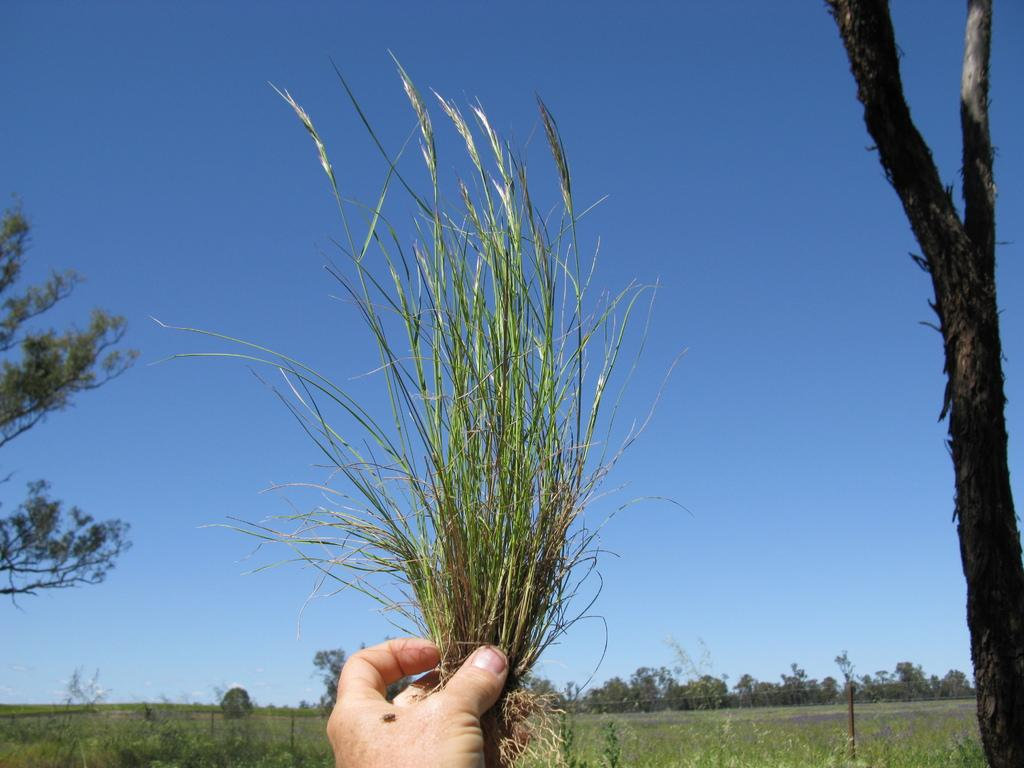What is the main subject in the center of the image? There is grass in the center of the image. How is the grass being held in the image? The grass appears to be held in a hand. What type of natural environment is visible in the background of the image? There is greenery and the sky visible in the background of the image. What object can be seen on the right side of the image? There is a trunk on the right side of the image. How many horses are running in the image? There are no horses present in the image. What type of power source is connected to the trunk in the image? There is no power source or connection visible in the image; it only shows a trunk and grass being held. 